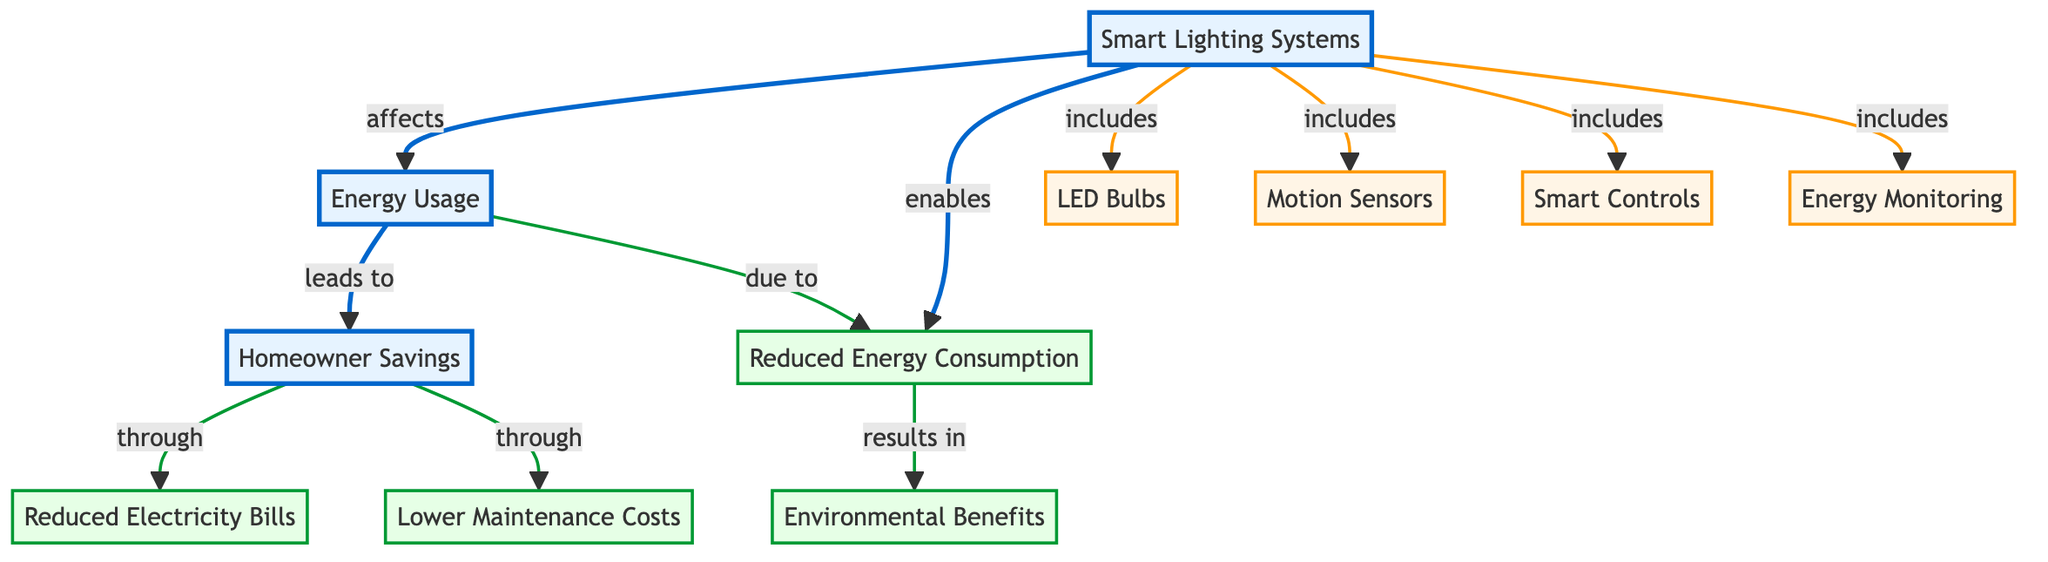What are the components included in smart lighting systems? The diagram mentions four components included within smart lighting systems: LED Bulbs, Motion Sensors, Smart Controls, and Energy Monitoring. All these components are branches directly associated with the main node of Smart Lighting Systems.
Answer: LED Bulbs, Motion Sensors, Smart Controls, Energy Monitoring How many benefits are listed in the diagram? The diagram lists four distinct benefits related to homeowner savings: Reduced Electricity Bills, Lower Maintenance Costs, Environmental Benefits, and Reduced Energy Consumption. Each benefit is connected to the main node for Homeowner Savings.
Answer: 4 What does reduced energy consumption lead to? According to the diagram, reduced energy consumption results in environmental benefits. This relationship shows how one positively affects the other, indicating the importance of energy-efficient systems in contributing to environmental protection.
Answer: Environmental Benefits What is the direct effect of smart lighting systems on energy usage? The diagram indicates that smart lighting systems directly affect energy usage, illustrating a straightforward relationship where the implementation of smart lighting systems has an impact on the overall energy usage within a home.
Answer: Energy Usage How do homeowner savings occur through reduced electricity bills? The diagram states that homeowner savings happen through reduced electricity bills, emphasizing that the financial benefit is achieved by lowering the amount spent on electricity, which is a direct outcome of using energy-efficient lighting solutions.
Answer: Reduced Electricity Bills What is the relationship between energy usage and energy consumption? The diagram shows that energy usage is influenced by reduced energy consumption, which means that when energy consumption is lowered, it directly affects the overall energy usage metric in a household or building.
Answer: Influenced by What enables reduced energy consumption according to the diagram? The diagram specifies that reduced energy consumption is enabled by the implementation of smart lighting systems. This indicates that using advanced lighting technology plays a crucial role in decreasing the energy consumed in homes.
Answer: Smart Lighting Systems How do environmental benefits relate to homeowner savings? The diagram illustrates that environmental benefits are a result of reduced energy consumption, which in turn is a component linked to homeowner savings. Therefore, by saving energy, homeowners also contribute to environmental sustainability, thus creating a beneficial cycle.
Answer: Result of Reduced Energy Consumption 